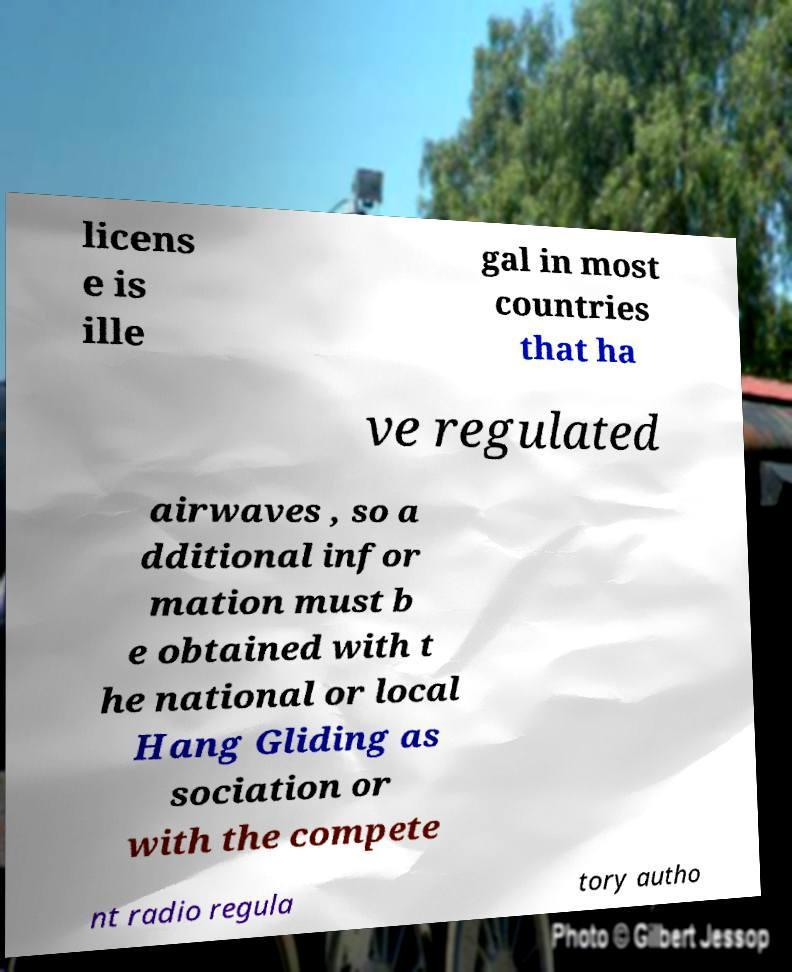What messages or text are displayed in this image? I need them in a readable, typed format. licens e is ille gal in most countries that ha ve regulated airwaves , so a dditional infor mation must b e obtained with t he national or local Hang Gliding as sociation or with the compete nt radio regula tory autho 